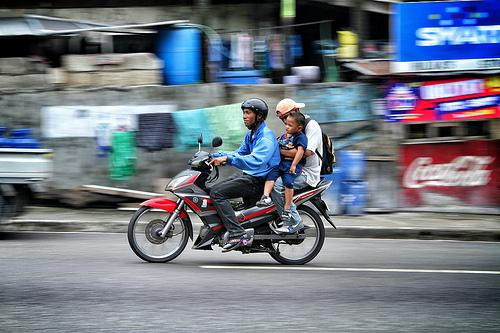What is the relationship between the passengers on the motorcycle? A man on the back of the motorcycle is holding a small child in his arms, implying a possible parent-child relationship. Examine the state of the road and describe if it is clear, clean or has any markings. The road is clean and clear, with a white line painted on the street. How many people are on the motorcycle and what are they wearing? Three people are on the motorcycle - a man wearing a blue jacket, a man wearing a white shirt and a baseball cap, and a small child wearing blue shorts. What is the main object and action taking place in the image? A man is riding a red motorcycle with two passengers, one holding a child, down the street. Point out the advertisement in the image, and what color is its text? There is a blurred Coca Cola advertisement next to the sidewalk with white cursive text. Can you spot any pieces of clothing or accessories on the people in the image? Yes, there are hats (a black helmet, an orange cap, and a baseball cap), a blue jacket, denim jeans, black shoes, white shirt, blue shorts, blue shirt, and a book bag. Identify any footwear worn by the motorcycle driver and passengers. The driver is wearing sandals, and the passengers wear no visible footwear. List the colors of the different objects in the image. Red motorcycle, black helmet, blue jacket, blue shirt, blue shorts, white shirt, orange cap, white road line, and blurred cursive white Coca Cola logo. What safety gear can you identify on the motorcycle and its driver? The motorcycle has rearview mirrors, and the driver is wearing a black helmet. Give details on the motorcycle wheels and tires. The front black wheel and the back black tire are both part of the motorcycle. Describe the appearance and attire of the man driving the motorcycle. The man is wearing a black helmet, blue jacket, denim jeans, and sandals on his feet. Identify the event depicted in the image. Three people riding on a red motorcycle. Create a brief story about the people on the motorcycle. A father picks up his friend and small child for a ride on his red motorcycle. As they drive down the street, they pass a blurred Coca-Cola advertisement on the sidewalk. What are the colors of the writings on the advertisement? The writings are white in color. Explain the structure and components of the motorcycle. The motorcycle has a red body, front and back black wheels, handlebars, and two rearview mirrors. What is the color of the road? The road is clean and clear. Describe the scene featuring a motorcycle and people. Three people riding on a red motorcycle, with the man driving wearing a black helmet, and a man on the back holding a small dark-skinned child in his arms. Select the most accurate description of the motorcycle. b) Blue motorcycle parked beside the road What is the man on the back of the motorcycle wearing on his head? An orange cap turned backwards. 